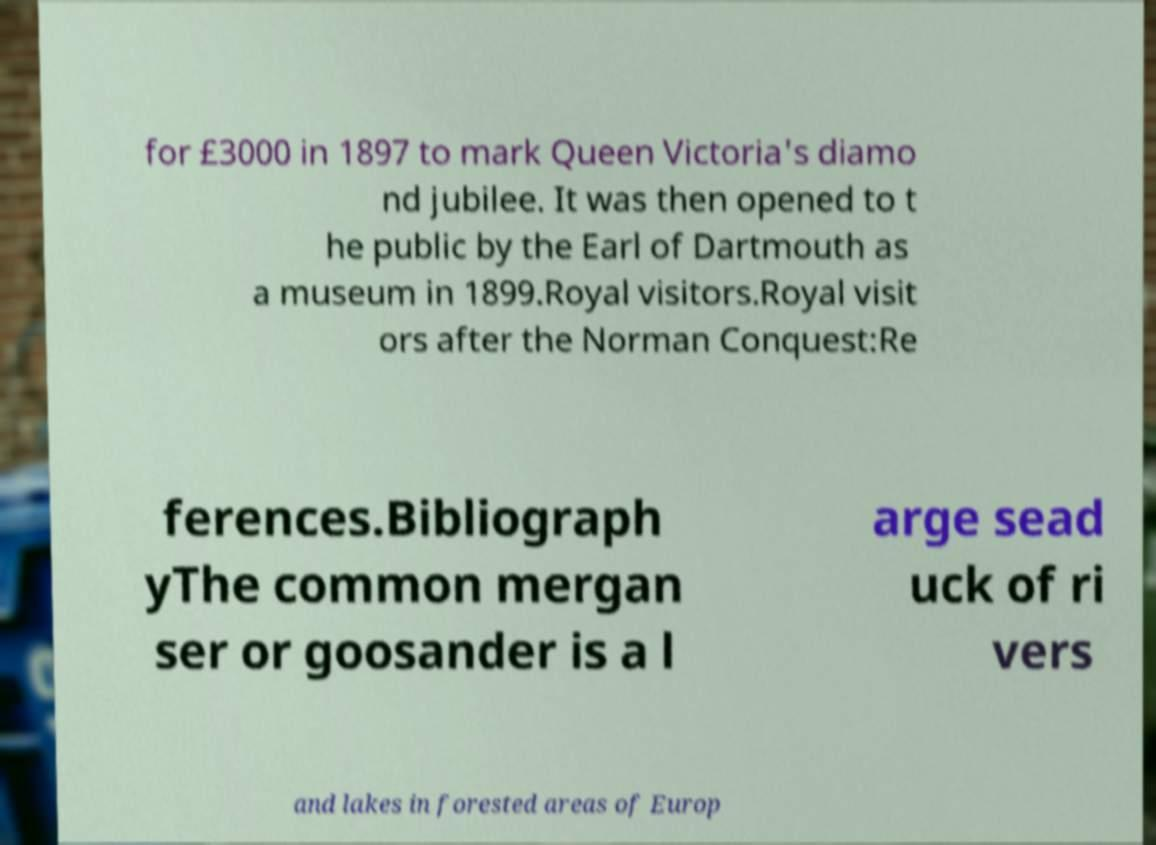I need the written content from this picture converted into text. Can you do that? for £3000 in 1897 to mark Queen Victoria's diamo nd jubilee. It was then opened to t he public by the Earl of Dartmouth as a museum in 1899.Royal visitors.Royal visit ors after the Norman Conquest:Re ferences.Bibliograph yThe common mergan ser or goosander is a l arge sead uck of ri vers and lakes in forested areas of Europ 